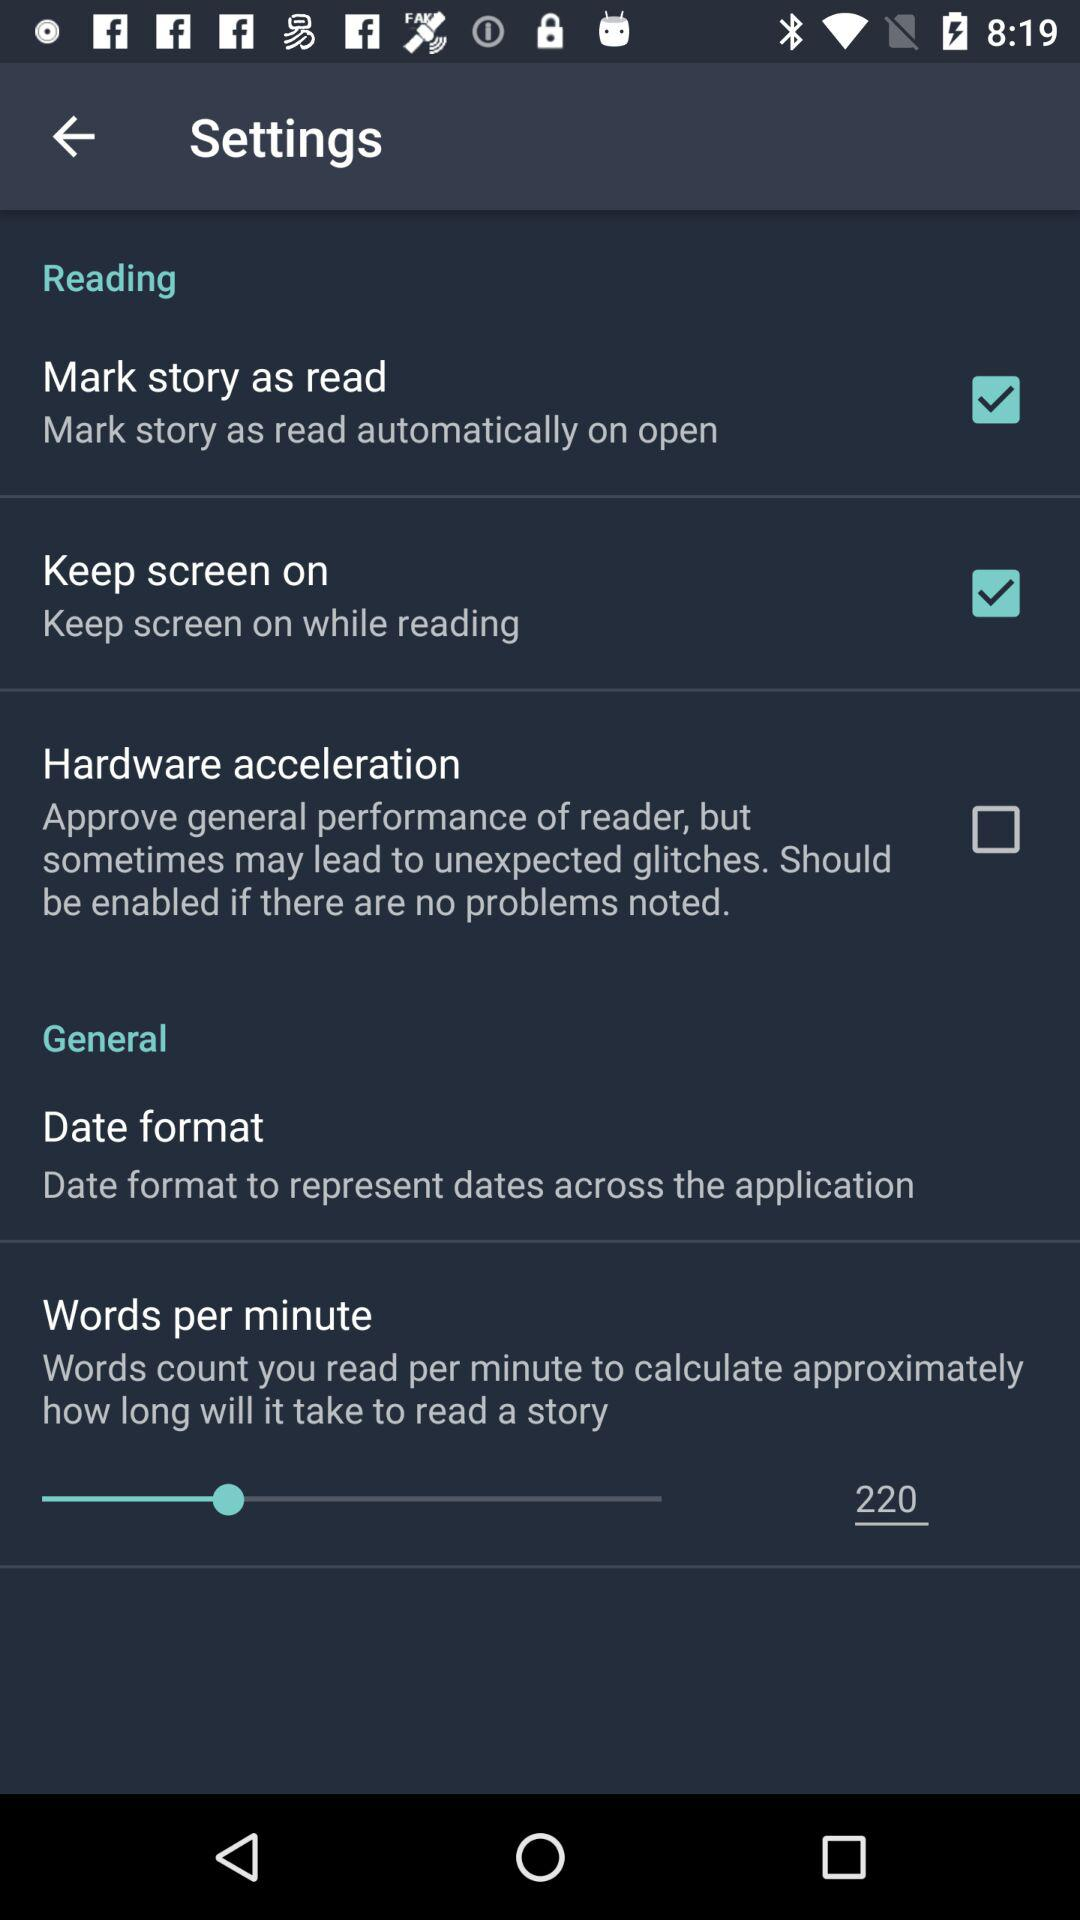What is the status of "Hardware acceleration"? The status is "off". 